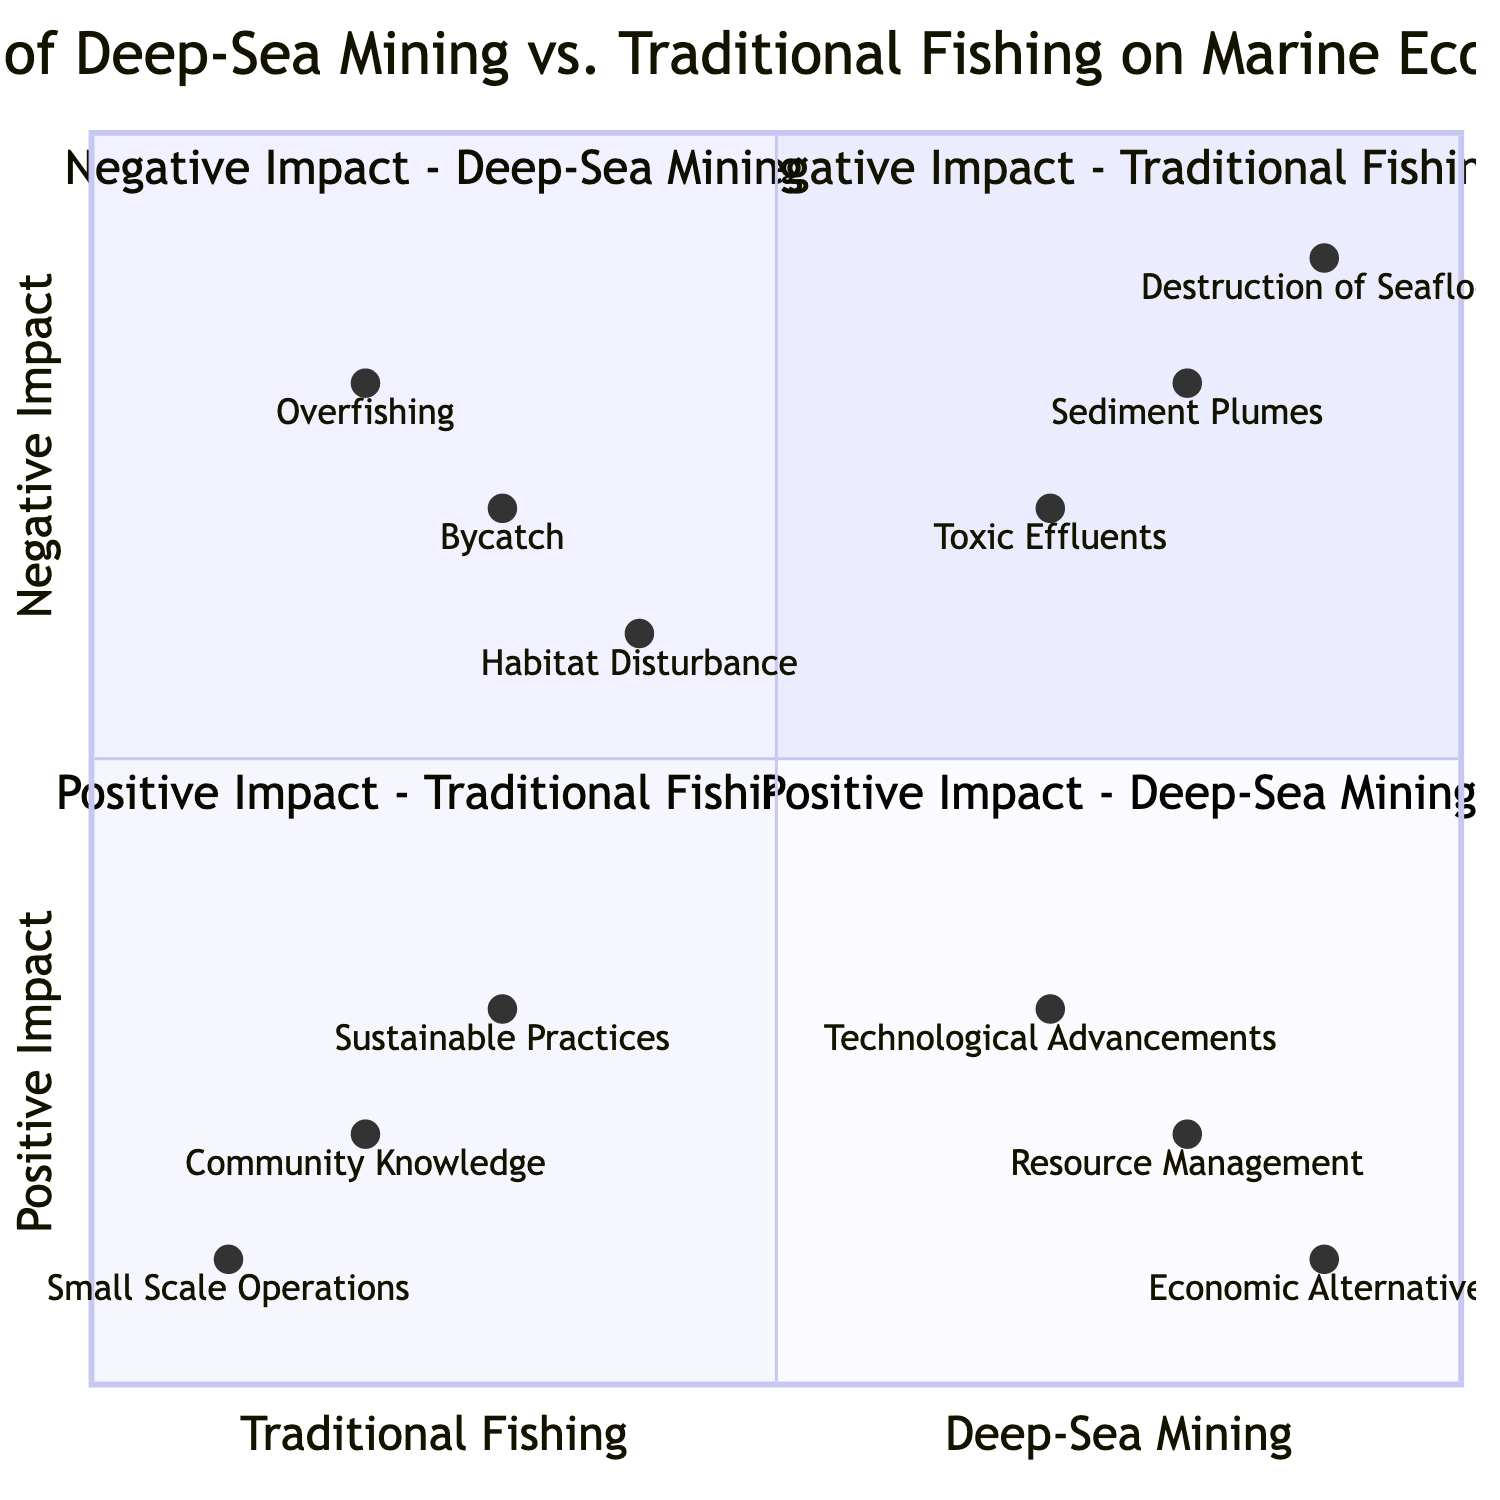What is the first element in the Negative Impact - Traditional Fishing quadrant? The first element listed in the Negative Impact - Traditional Fishing quadrant is "Overfishing". This can be found in the TopLeft section of the quadrant chart.
Answer: Overfishing How many elements are in the Positive Impact - Deep-Sea Mining quadrant? In the Positive Impact - Deep-Sea Mining quadrant, there are three elements listed: "Technological Advancements," "Resource Management," and "Economic Alternatives." This indicates a count of these specific elements.
Answer: 3 Which fishing method has a more significant negative impact on the marine ecosystem, based on the quadrant chart? Observing the elements in the top quadrants, "Deep-Sea Mining" seems to have more significant entries such as "Destruction of Seafloor Habitats" and "Toxic Effluents," suggesting a greater negative impact compared to "Overfishing" from traditional fishing.
Answer: Deep-Sea Mining What is the general trend for the "Sustainable Practices" element in the diagram? The element "Sustainable Practices" is located in the BottomLeft quadrant, indicating it has a positive impact on the marine ecosystem. This suggests that sustainable fishing methods help improve ecosystem health rather than degrade it.
Answer: Positive Impact Which element in the chart relates to the harmful substances from mining operations? The element that relates to harmful substances from mining operations is "Toxic Effluents," found in the TopRight quadrant under Deep-Sea Mining. This indicates that such substances can contaminate marine environments negatively.
Answer: Toxic Effluents What quadrant represents both fishing methods having a negative impact? The quadrants in the chart that represent negative impacts are TopLeft for Traditional Fishing and TopRight for Deep-Sea Mining. Therefore, the answer encompasses both quadrants.
Answer: TopLeft and TopRight Which positive impact of traditional fishing emphasizes community involvement? The element that emphasizes community involvement in traditional fishing is "Community Knowledge," found in the BottomLeft quadrant, indicating the role of local fishermen in preserving marine ecosystems.
Answer: Community Knowledge What fishing method appears to have technological advancements aimed at reducing environmental harm? The fishing method associated with technological advancements aimed at mitigation is "Deep-Sea Mining," as indicated in the BottomRight quadrant, showcasing efforts to lessen environmental impacts.
Answer: Deep-Sea Mining Which fishing method has elements suggesting a smaller environmental footprint? The traditional fishing method elements such as "Small Scale Operations" are located in the BottomLeft quadrant, which suggests a smaller environmental footprint compared to industrial methods.
Answer: Traditional Fishing 